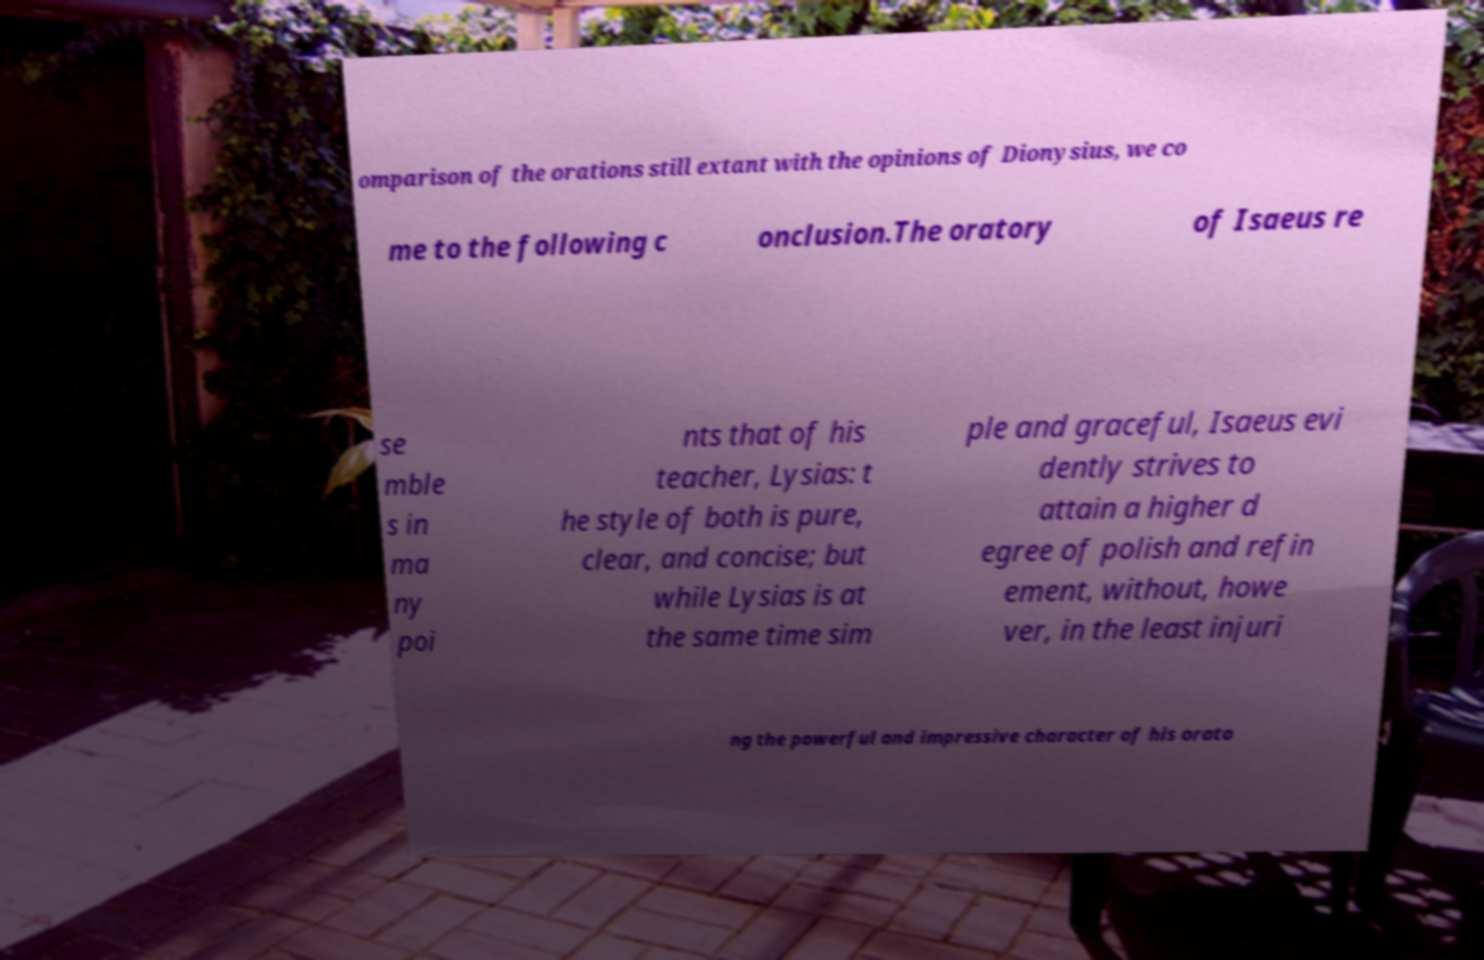Can you read and provide the text displayed in the image?This photo seems to have some interesting text. Can you extract and type it out for me? omparison of the orations still extant with the opinions of Dionysius, we co me to the following c onclusion.The oratory of Isaeus re se mble s in ma ny poi nts that of his teacher, Lysias: t he style of both is pure, clear, and concise; but while Lysias is at the same time sim ple and graceful, Isaeus evi dently strives to attain a higher d egree of polish and refin ement, without, howe ver, in the least injuri ng the powerful and impressive character of his orato 